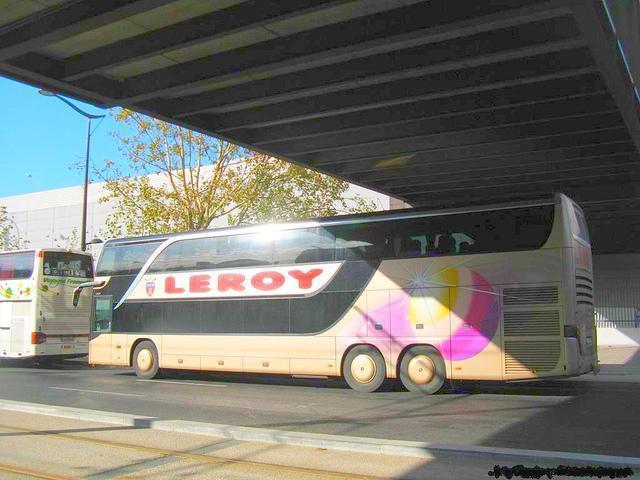How many buses are visible?
Give a very brief answer. 2. 